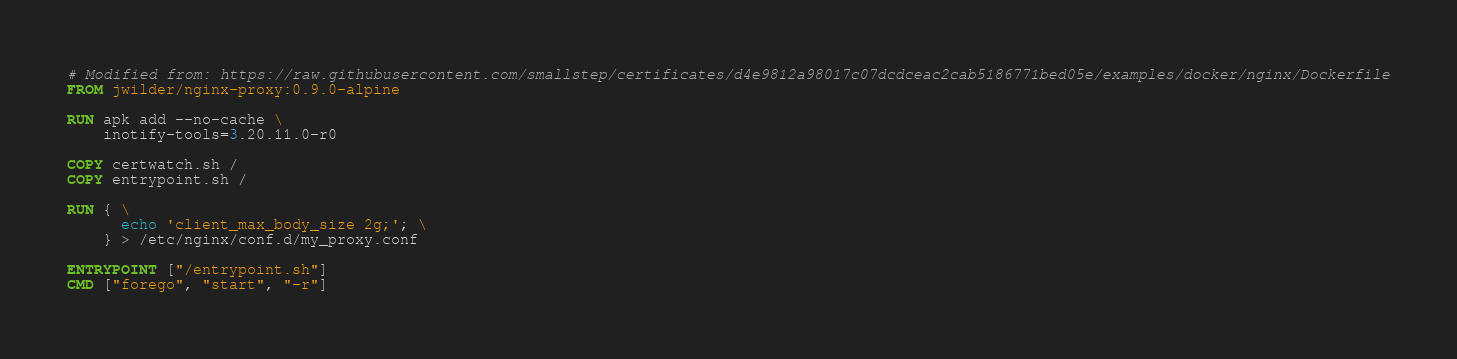Convert code to text. <code><loc_0><loc_0><loc_500><loc_500><_Dockerfile_># Modified from: https://raw.githubusercontent.com/smallstep/certificates/d4e9812a98017c07dcdceac2cab5186771bed05e/examples/docker/nginx/Dockerfile
FROM jwilder/nginx-proxy:0.9.0-alpine

RUN apk add --no-cache \
    inotify-tools=3.20.11.0-r0

COPY certwatch.sh /
COPY entrypoint.sh /

RUN { \
      echo 'client_max_body_size 2g;'; \
    } > /etc/nginx/conf.d/my_proxy.conf

ENTRYPOINT ["/entrypoint.sh"]
CMD ["forego", "start", "-r"]
</code> 